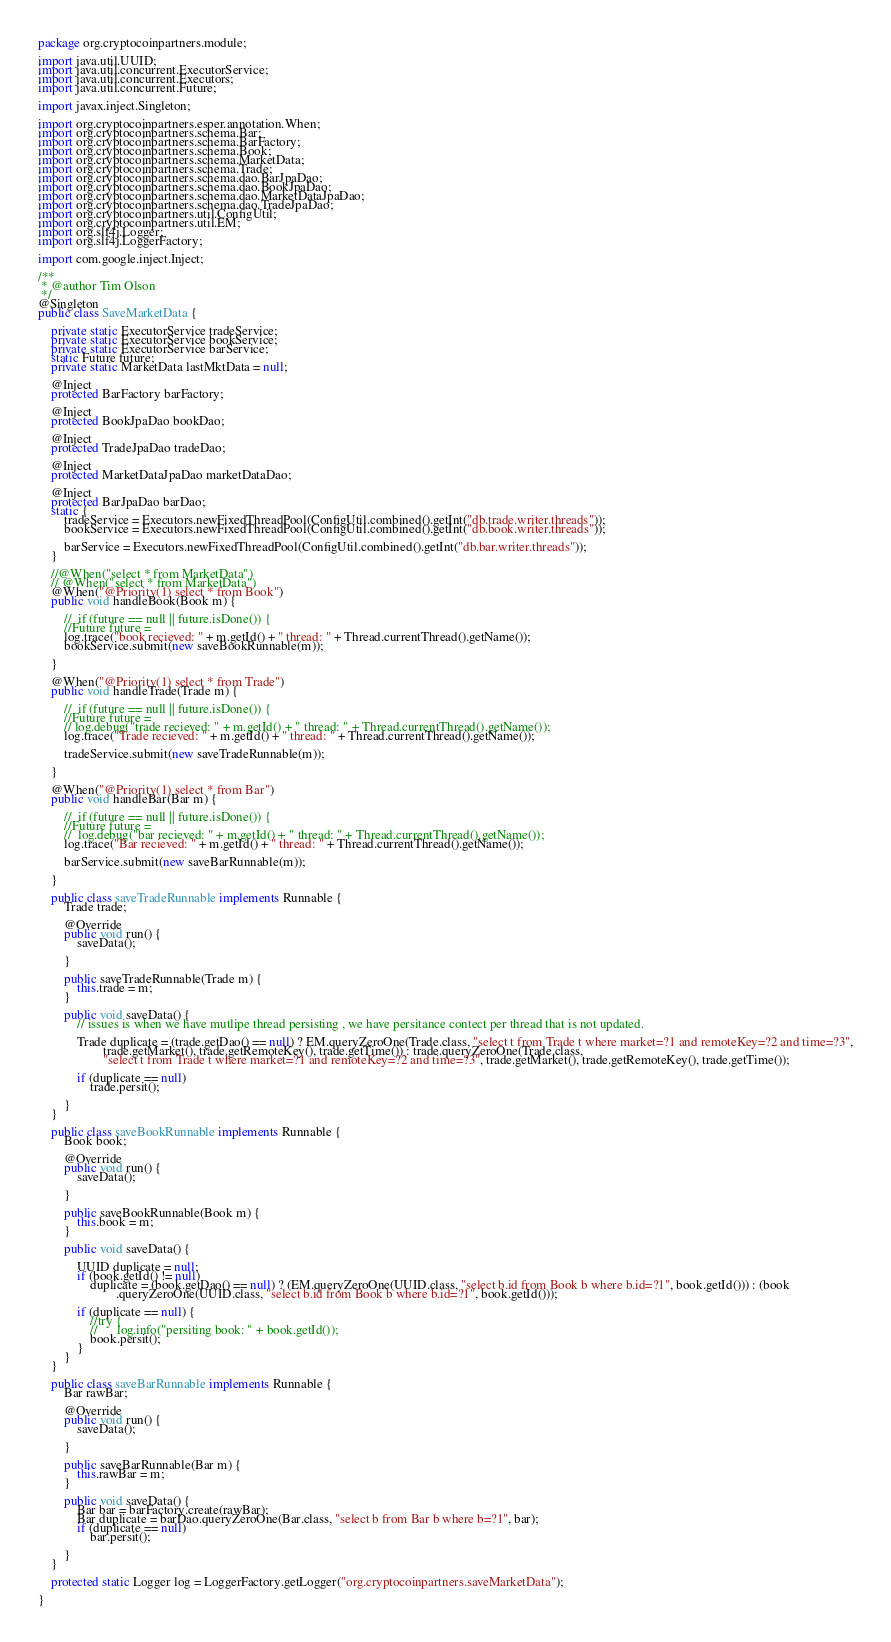Convert code to text. <code><loc_0><loc_0><loc_500><loc_500><_Java_>package org.cryptocoinpartners.module;

import java.util.UUID;
import java.util.concurrent.ExecutorService;
import java.util.concurrent.Executors;
import java.util.concurrent.Future;

import javax.inject.Singleton;

import org.cryptocoinpartners.esper.annotation.When;
import org.cryptocoinpartners.schema.Bar;
import org.cryptocoinpartners.schema.BarFactory;
import org.cryptocoinpartners.schema.Book;
import org.cryptocoinpartners.schema.MarketData;
import org.cryptocoinpartners.schema.Trade;
import org.cryptocoinpartners.schema.dao.BarJpaDao;
import org.cryptocoinpartners.schema.dao.BookJpaDao;
import org.cryptocoinpartners.schema.dao.MarketDataJpaDao;
import org.cryptocoinpartners.schema.dao.TradeJpaDao;
import org.cryptocoinpartners.util.ConfigUtil;
import org.cryptocoinpartners.util.EM;
import org.slf4j.Logger;
import org.slf4j.LoggerFactory;

import com.google.inject.Inject;

/**
 * @author Tim Olson
 */
@Singleton
public class SaveMarketData {

    private static ExecutorService tradeService;
    private static ExecutorService bookService;
    private static ExecutorService barService;
    static Future future;
    private static MarketData lastMktData = null;

    @Inject
    protected BarFactory barFactory;

    @Inject
    protected BookJpaDao bookDao;

    @Inject
    protected TradeJpaDao tradeDao;

    @Inject
    protected MarketDataJpaDao marketDataDao;

    @Inject
    protected BarJpaDao barDao;
    static {
        tradeService = Executors.newFixedThreadPool(ConfigUtil.combined().getInt("db.trade.writer.threads"));
        bookService = Executors.newFixedThreadPool(ConfigUtil.combined().getInt("db.book.writer.threads"));

        barService = Executors.newFixedThreadPool(ConfigUtil.combined().getInt("db.bar.writer.threads"));
    }

    //@When("select * from MarketData")
    // @When("select * from MarketData")
    @When("@Priority(1) select * from Book")
    public void handleBook(Book m) {

        //  if (future == null || future.isDone()) {
        //Future future = 
        log.trace("book recieved: " + m.getId() + " thread: " + Thread.currentThread().getName());
        bookService.submit(new saveBookRunnable(m));

    }

    @When("@Priority(1) select * from Trade")
    public void handleTrade(Trade m) {

        //  if (future == null || future.isDone()) {
        //Future future = 
        // log.debug("trade recieved: " + m.getId() + " thread: " + Thread.currentThread().getName());
        log.trace("Trade recieved: " + m.getId() + " thread: " + Thread.currentThread().getName());

        tradeService.submit(new saveTradeRunnable(m));

    }

    @When("@Priority(1) select * from Bar")
    public void handleBar(Bar m) {

        //  if (future == null || future.isDone()) {
        //Future future = 
        //  log.debug("bar recieved: " + m.getId() + " thread: " + Thread.currentThread().getName());
        log.trace("Bar recieved: " + m.getId() + " thread: " + Thread.currentThread().getName());

        barService.submit(new saveBarRunnable(m));

    }

    public class saveTradeRunnable implements Runnable {
        Trade trade;

        @Override
        public void run() {
            saveData();

        }

        public saveTradeRunnable(Trade m) {
            this.trade = m;
        }

        public void saveData() {
            // issues is when we have mutlipe thread persisting , we have persitance contect per thread that is not updated.

            Trade duplicate = (trade.getDao() == null) ? EM.queryZeroOne(Trade.class, "select t from Trade t where market=?1 and remoteKey=?2 and time=?3",
                    trade.getMarket(), trade.getRemoteKey(), trade.getTime()) : trade.queryZeroOne(Trade.class,
                    "select t from Trade t where market=?1 and remoteKey=?2 and time=?3", trade.getMarket(), trade.getRemoteKey(), trade.getTime());

            if (duplicate == null)
                trade.persit();

        }
    }

    public class saveBookRunnable implements Runnable {
        Book book;

        @Override
        public void run() {
            saveData();

        }

        public saveBookRunnable(Book m) {
            this.book = m;
        }

        public void saveData() {

            UUID duplicate = null;
            if (book.getId() != null)
                duplicate = (book.getDao() == null) ? (EM.queryZeroOne(UUID.class, "select b.id from Book b where b.id=?1", book.getId())) : (book
                        .queryZeroOne(UUID.class, "select b.id from Book b where b.id=?1", book.getId()));

            if (duplicate == null) {
                //try {
                //      log.info("persiting book: " + book.getId());
                book.persit();
            }
        }
    }

    public class saveBarRunnable implements Runnable {
        Bar rawBar;

        @Override
        public void run() {
            saveData();

        }

        public saveBarRunnable(Bar m) {
            this.rawBar = m;
        }

        public void saveData() {
            Bar bar = barFactory.create(rawBar);
            Bar duplicate = barDao.queryZeroOne(Bar.class, "select b from Bar b where b=?1", bar);
            if (duplicate == null)
                bar.persit();

        }
    }

    protected static Logger log = LoggerFactory.getLogger("org.cryptocoinpartners.saveMarketData");

}
</code> 